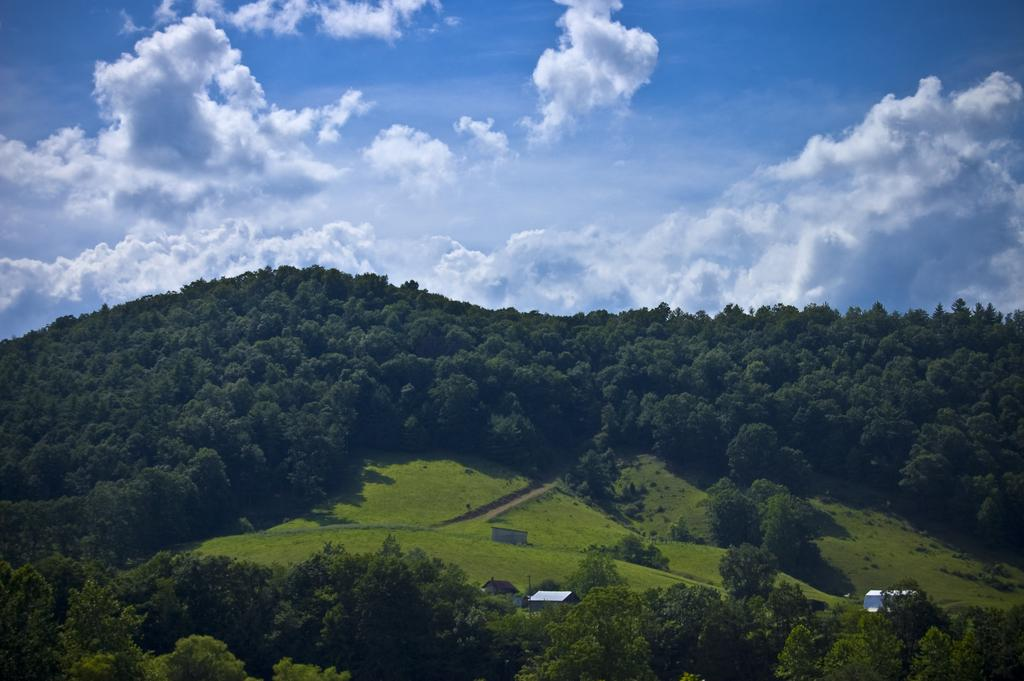What type of natural landscape is depicted in the image? The image features mountains. What can be seen on the mountains? The mountains are covered with trees, and there is green grass on them. Are there any man-made structures visible in the image? Yes, there are buildings visible in the image. What is visible at the top of the image? The sky is visible at the top of the image. What type of book can be seen on the mountains in the image? There is no book present in the image; it features mountains covered with trees and grass, buildings, and the sky. 